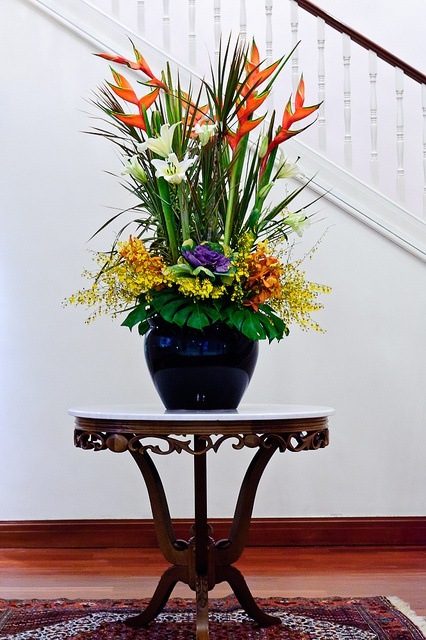Describe the objects in this image and their specific colors. I can see potted plant in white, black, lightgray, darkgreen, and olive tones and vase in white, black, navy, darkgreen, and darkblue tones in this image. 